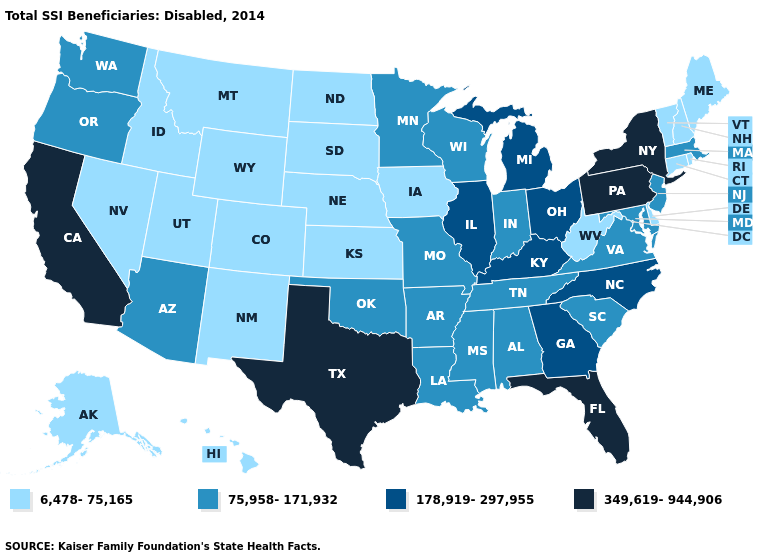Is the legend a continuous bar?
Keep it brief. No. What is the value of Delaware?
Keep it brief. 6,478-75,165. What is the value of Connecticut?
Answer briefly. 6,478-75,165. Does Vermont have the lowest value in the USA?
Answer briefly. Yes. Name the states that have a value in the range 75,958-171,932?
Short answer required. Alabama, Arizona, Arkansas, Indiana, Louisiana, Maryland, Massachusetts, Minnesota, Mississippi, Missouri, New Jersey, Oklahoma, Oregon, South Carolina, Tennessee, Virginia, Washington, Wisconsin. Name the states that have a value in the range 178,919-297,955?
Be succinct. Georgia, Illinois, Kentucky, Michigan, North Carolina, Ohio. Which states have the lowest value in the USA?
Keep it brief. Alaska, Colorado, Connecticut, Delaware, Hawaii, Idaho, Iowa, Kansas, Maine, Montana, Nebraska, Nevada, New Hampshire, New Mexico, North Dakota, Rhode Island, South Dakota, Utah, Vermont, West Virginia, Wyoming. Which states have the lowest value in the West?
Be succinct. Alaska, Colorado, Hawaii, Idaho, Montana, Nevada, New Mexico, Utah, Wyoming. What is the value of Oregon?
Concise answer only. 75,958-171,932. What is the highest value in the USA?
Keep it brief. 349,619-944,906. What is the lowest value in the USA?
Answer briefly. 6,478-75,165. Name the states that have a value in the range 178,919-297,955?
Answer briefly. Georgia, Illinois, Kentucky, Michigan, North Carolina, Ohio. What is the value of Nevada?
Short answer required. 6,478-75,165. Does New Hampshire have the lowest value in the Northeast?
Keep it brief. Yes. What is the lowest value in the Northeast?
Be succinct. 6,478-75,165. 